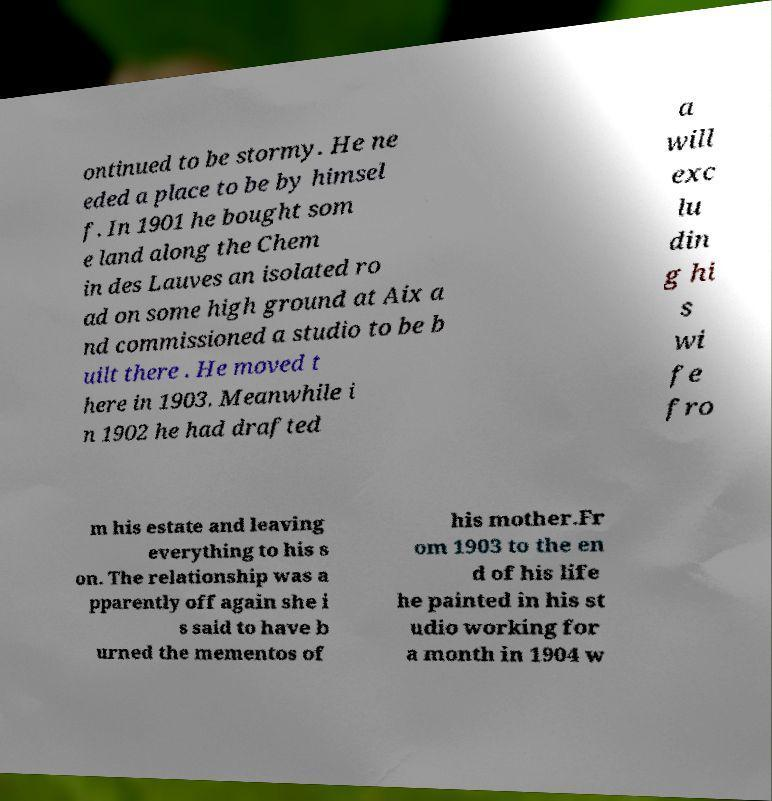Can you read and provide the text displayed in the image?This photo seems to have some interesting text. Can you extract and type it out for me? ontinued to be stormy. He ne eded a place to be by himsel f. In 1901 he bought som e land along the Chem in des Lauves an isolated ro ad on some high ground at Aix a nd commissioned a studio to be b uilt there . He moved t here in 1903. Meanwhile i n 1902 he had drafted a will exc lu din g hi s wi fe fro m his estate and leaving everything to his s on. The relationship was a pparently off again she i s said to have b urned the mementos of his mother.Fr om 1903 to the en d of his life he painted in his st udio working for a month in 1904 w 